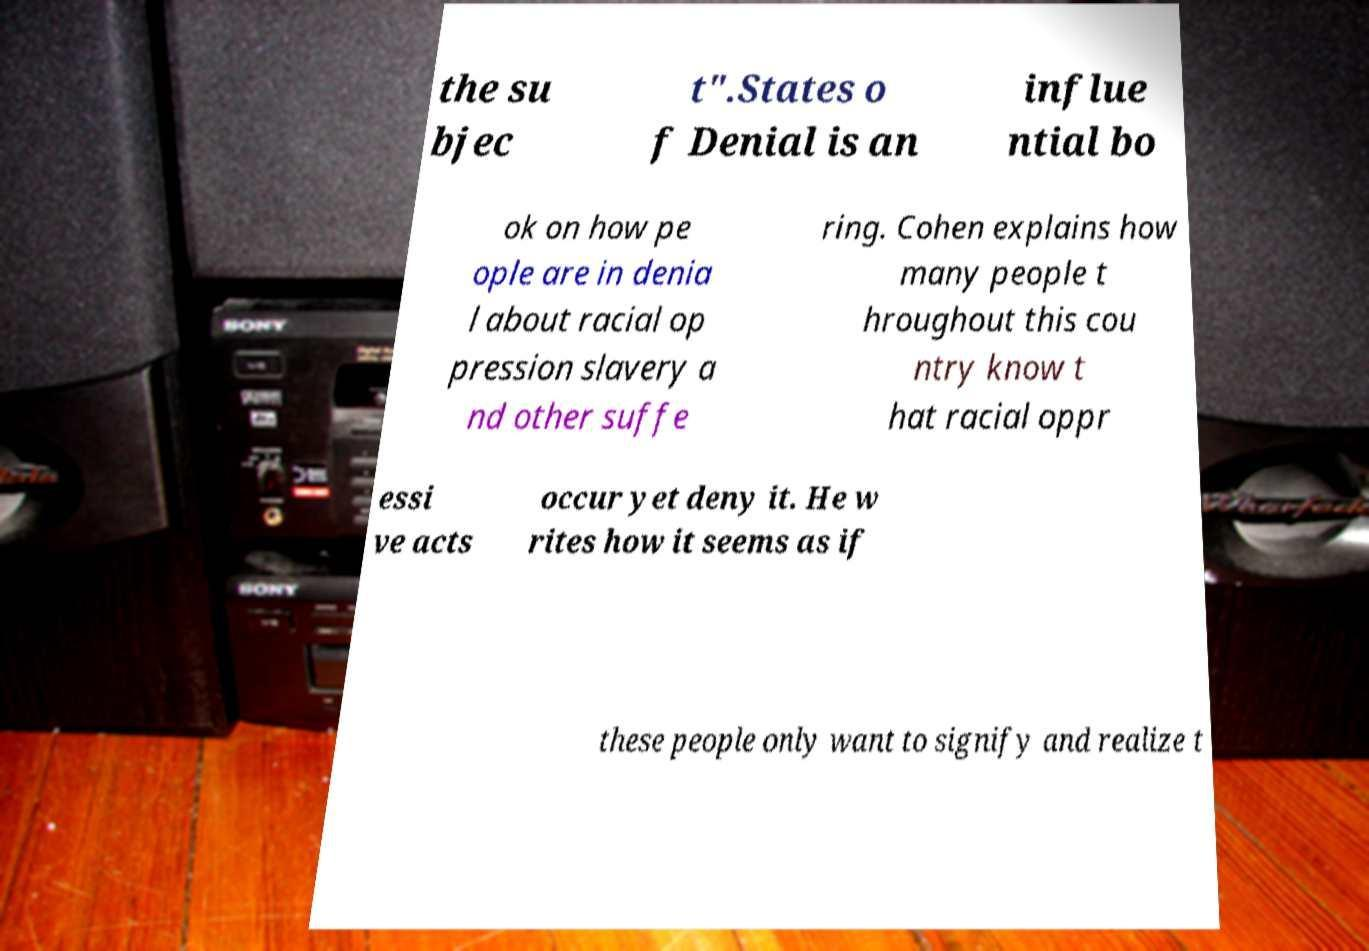I need the written content from this picture converted into text. Can you do that? the su bjec t".States o f Denial is an influe ntial bo ok on how pe ople are in denia l about racial op pression slavery a nd other suffe ring. Cohen explains how many people t hroughout this cou ntry know t hat racial oppr essi ve acts occur yet deny it. He w rites how it seems as if these people only want to signify and realize t 